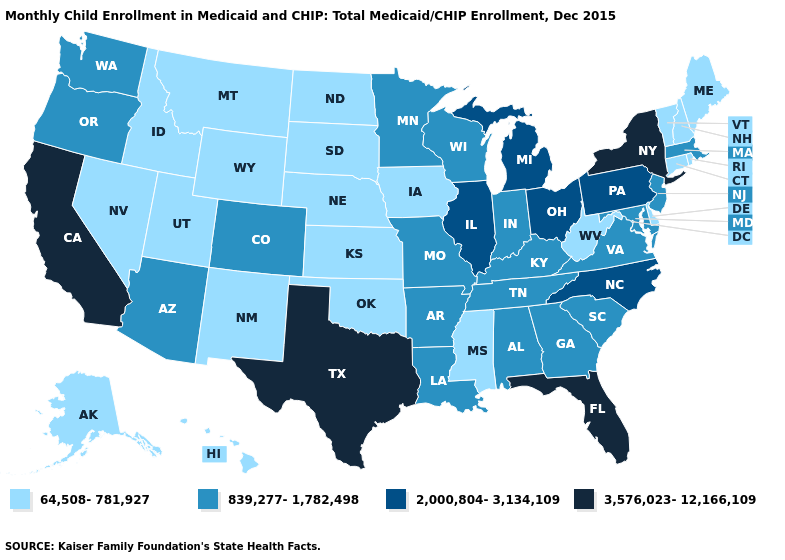What is the highest value in the USA?
Give a very brief answer. 3,576,023-12,166,109. What is the value of Missouri?
Quick response, please. 839,277-1,782,498. Does Arkansas have a lower value than Montana?
Concise answer only. No. Does California have the highest value in the USA?
Give a very brief answer. Yes. Name the states that have a value in the range 3,576,023-12,166,109?
Write a very short answer. California, Florida, New York, Texas. Does North Dakota have the lowest value in the USA?
Write a very short answer. Yes. What is the value of Nebraska?
Give a very brief answer. 64,508-781,927. What is the value of Wyoming?
Write a very short answer. 64,508-781,927. Which states have the highest value in the USA?
Concise answer only. California, Florida, New York, Texas. What is the value of Massachusetts?
Concise answer only. 839,277-1,782,498. How many symbols are there in the legend?
Quick response, please. 4. What is the value of Mississippi?
Short answer required. 64,508-781,927. What is the highest value in the USA?
Be succinct. 3,576,023-12,166,109. Which states hav the highest value in the MidWest?
Short answer required. Illinois, Michigan, Ohio. Which states hav the highest value in the West?
Quick response, please. California. 